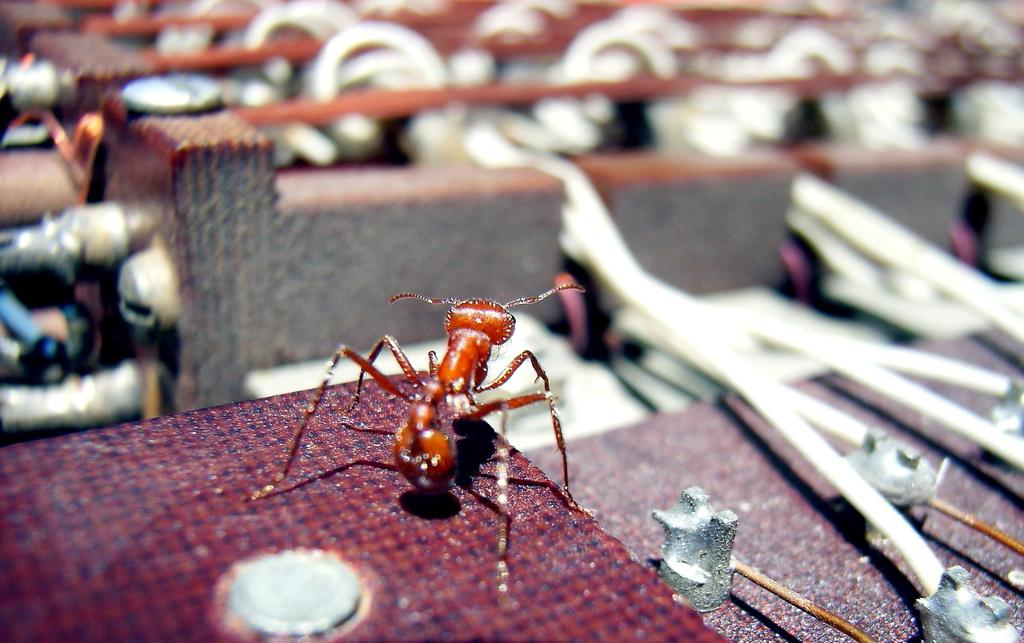What type of creature can be seen in the image? There is an insect in the image. Where is the insect located? The insect is on a stand in the image. What can be seen in the background of the image? There are rods visible in the background of the image. What type of furniture is present in the image? There is a table in the image. What type of pen is the insect using to write a voyage in the image? There is no pen or writing activity depicted in the image; it features an insect on a stand with rods in the background and a table. 